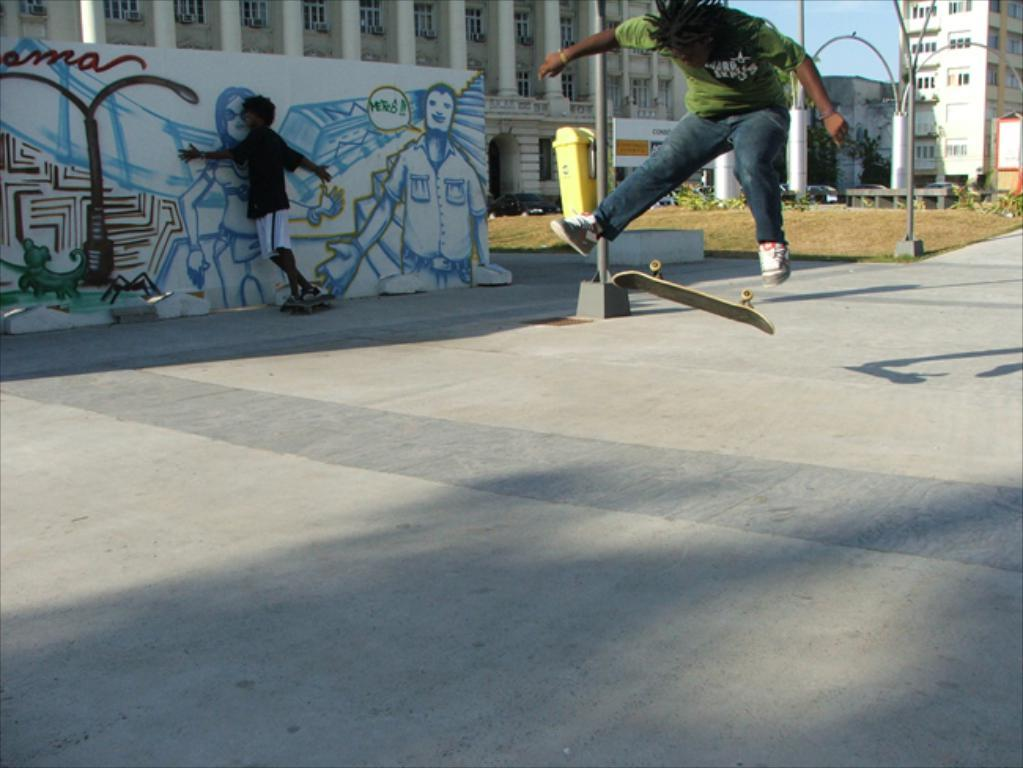What are the two persons in the image doing? The two persons are doing skating in the image. What can be seen in the background of the image? There are poles, a banner, plants, and buildings visible in the background of the image. What type of silk is being used by the giraffe in the image? There is no giraffe or silk present in the image. What color is the notebook on the ice rink in the image? There is no notebook visible in the image; it is focused on the two persons skating and the background elements. 